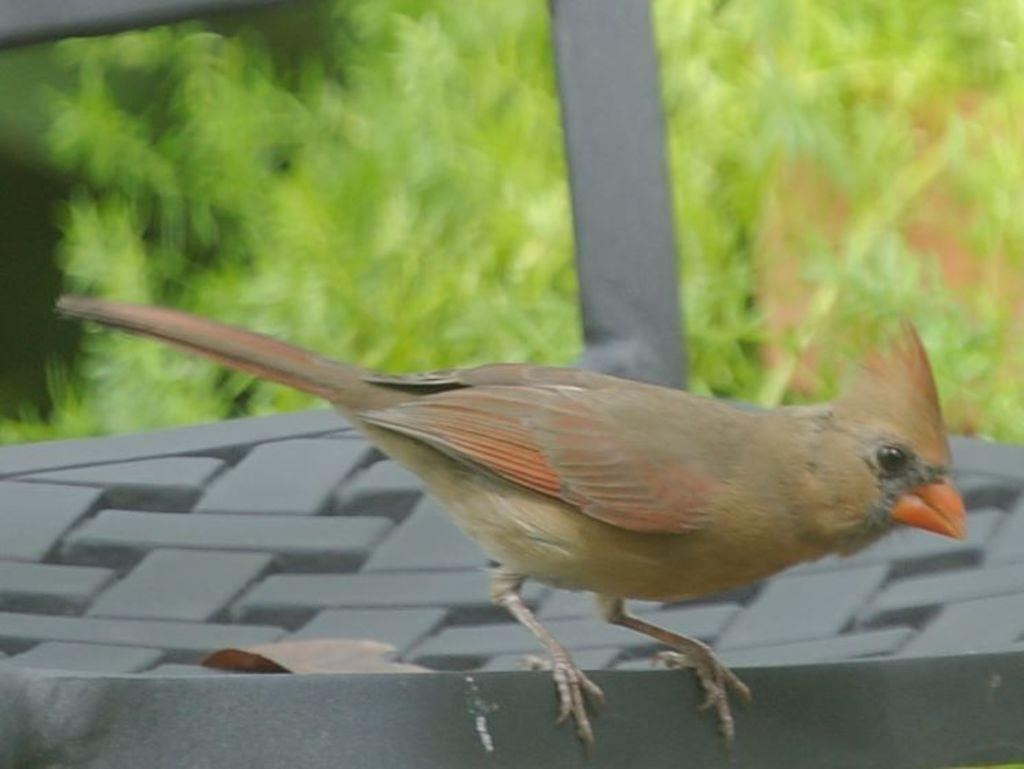What type of animal is on the surface in the image? There is a bird on the surface in the image. How would you describe the background of the image? The background of the image is blurred. What type of vegetation can be seen in the image? Leaves and plants are visible in the image. What type of appliance is being used to test the theory in the image? There is no appliance or theory present in the image; it features a bird on a surface with a blurred background and vegetation. 